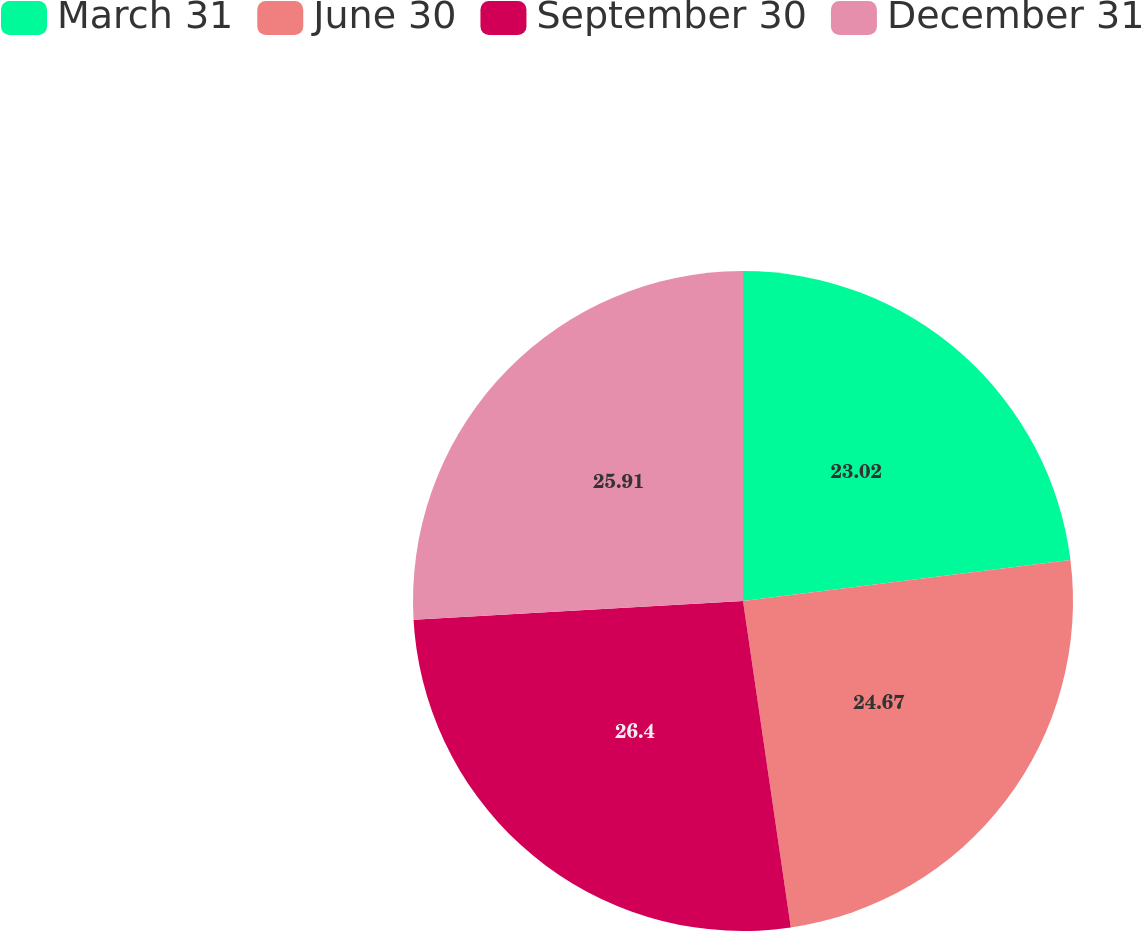Convert chart. <chart><loc_0><loc_0><loc_500><loc_500><pie_chart><fcel>March 31<fcel>June 30<fcel>September 30<fcel>December 31<nl><fcel>23.02%<fcel>24.67%<fcel>26.41%<fcel>25.91%<nl></chart> 